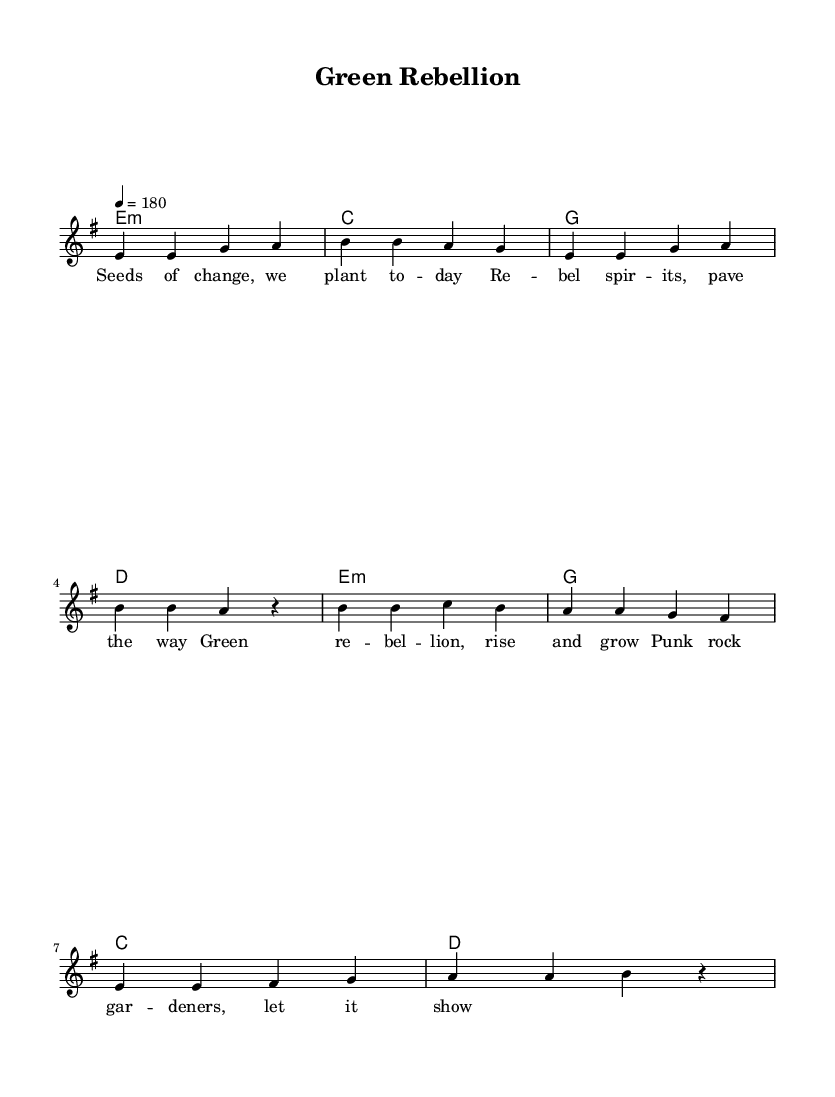What is the key signature of this music? The key signature is indicated by the overall structure of the score. The music is in E minor, which contains one sharp (F#) in its key signature.
Answer: E minor What is the time signature? The time signature is shown at the beginning of the score. It is written as 4/4, meaning there are four beats in each measure and a quarter note gets one beat.
Answer: 4/4 What is the tempo marking for this piece? The tempo is indicated in the score, where it is stated as 4 = 180. This means that the quarter note should be played at a speed of 180 beats per minute.
Answer: 180 How many measures are there in the verse? To determine the number of measures in the verse, we count the measures in the melody section labeled for the verse, which consists of four lines of music, with each line containing two measures. Thus, there are a total of 8 measures.
Answer: 8 What type of environmental theme is presented in the lyrics? The lyrics indicate a theme of change and rebellion in relation to nature, emphasizing gardening, growth, and activism. The phrase "Green rebellion" and terms like "Seeds of change" suggest a call to action for environmental awareness and gardening.
Answer: Gardening What is the primary emotion conveyed in the chorus? The chorus expresses a sense of empowerment and unity among "punk rock gardeners," suggesting a collective strength and motivation to act for the environment. The lyrics evoke an uplifting, rebellious spirit associated with punk music and environmental activism.
Answer: Empowerment Which chord follows the verse melody first? The first chord in the chord progression for the verse section appears right after the melody starts, and it is E minor, which acts as the tonic chord in the context of the E minor key.
Answer: E minor 